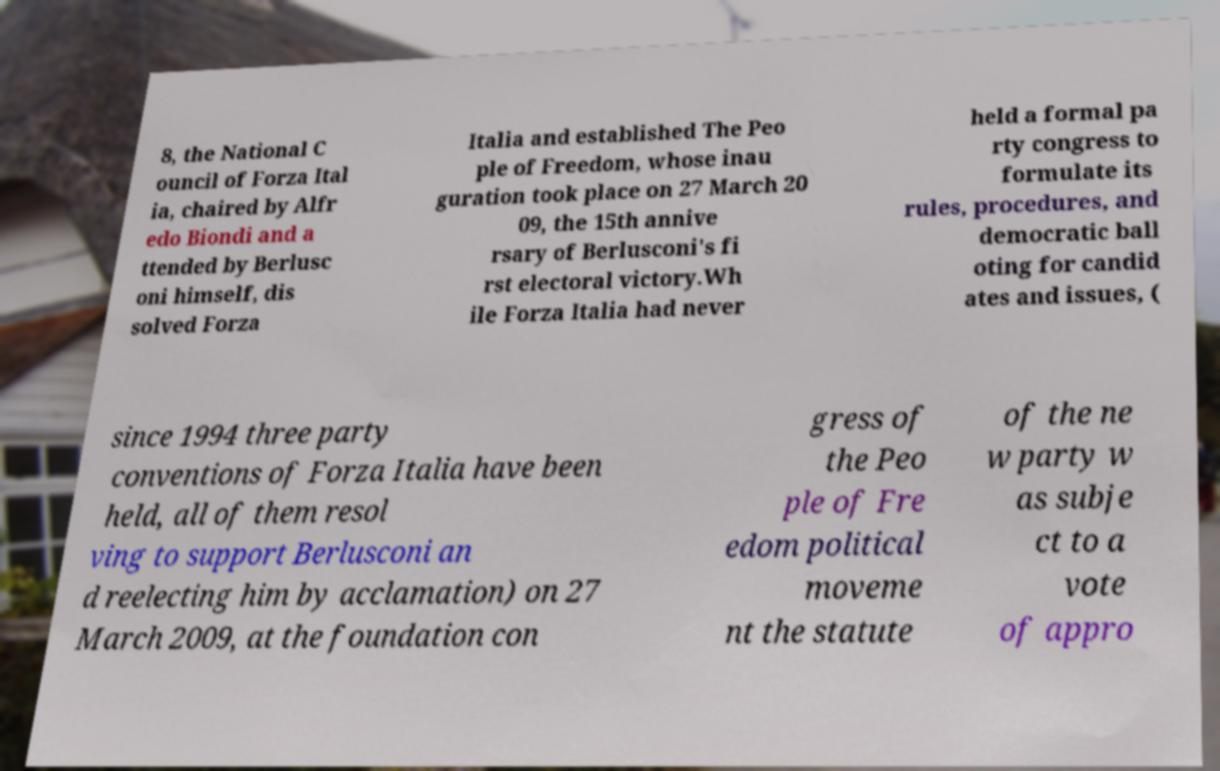Please identify and transcribe the text found in this image. 8, the National C ouncil of Forza Ital ia, chaired by Alfr edo Biondi and a ttended by Berlusc oni himself, dis solved Forza Italia and established The Peo ple of Freedom, whose inau guration took place on 27 March 20 09, the 15th annive rsary of Berlusconi's fi rst electoral victory.Wh ile Forza Italia had never held a formal pa rty congress to formulate its rules, procedures, and democratic ball oting for candid ates and issues, ( since 1994 three party conventions of Forza Italia have been held, all of them resol ving to support Berlusconi an d reelecting him by acclamation) on 27 March 2009, at the foundation con gress of the Peo ple of Fre edom political moveme nt the statute of the ne w party w as subje ct to a vote of appro 